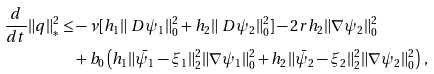Convert formula to latex. <formula><loc_0><loc_0><loc_500><loc_500>\frac { d } { d t } \| q \| _ { * } ^ { 2 } \leq & - \nu [ h _ { 1 } \| \ D \psi _ { 1 } \| _ { 0 } ^ { 2 } + h _ { 2 } \| \ D \psi _ { 2 } \| _ { 0 } ^ { 2 } ] - 2 r h _ { 2 } \| \nabla \psi _ { 2 } \| _ { 0 } ^ { 2 } \\ & + b _ { 0 } \left ( h _ { 1 } \| \bar { \psi } _ { 1 } - \xi _ { 1 } \| _ { 2 } ^ { 2 } \| \nabla \psi _ { 1 } \| _ { 0 } ^ { 2 } + h _ { 2 } \| \bar { \psi } _ { 2 } - \xi _ { 2 } \| _ { 2 } ^ { 2 } \| \nabla \psi _ { 2 } \| _ { 0 } ^ { 2 } \right ) \, ,</formula> 